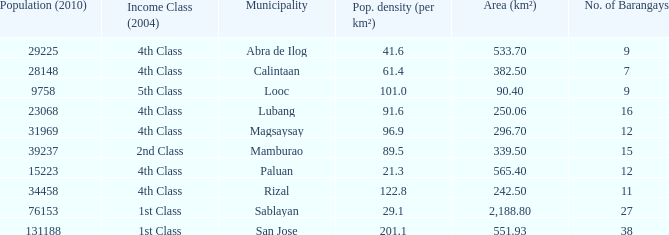What is the population density for the city of lubang? 1.0. 